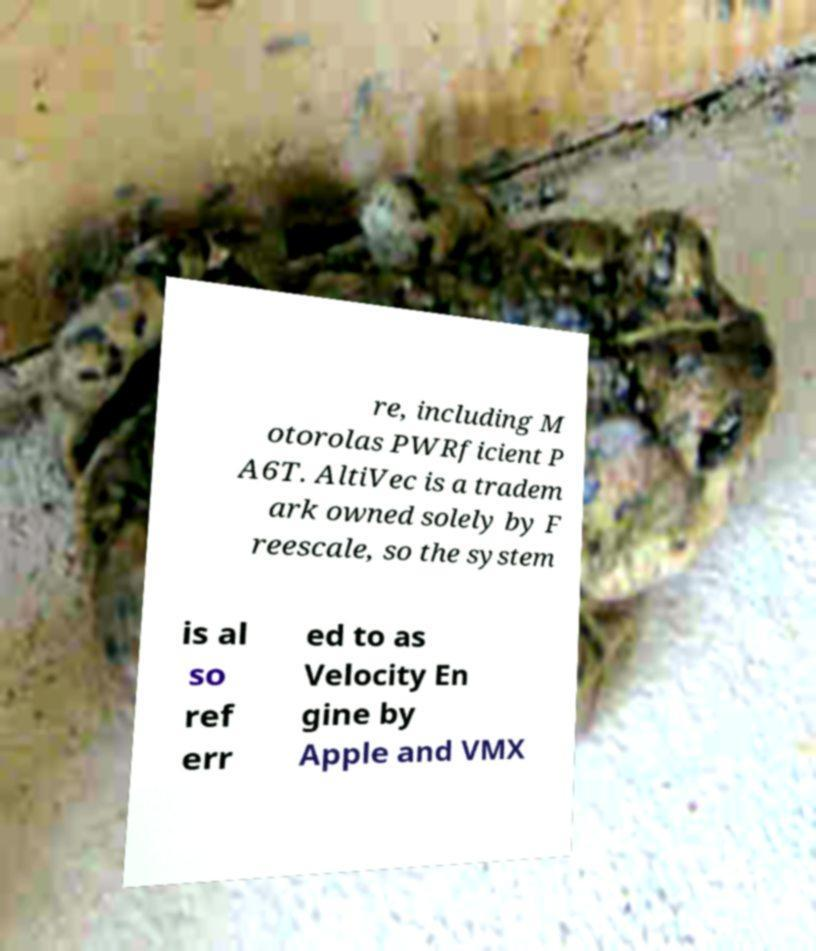Can you accurately transcribe the text from the provided image for me? re, including M otorolas PWRficient P A6T. AltiVec is a tradem ark owned solely by F reescale, so the system is al so ref err ed to as Velocity En gine by Apple and VMX 